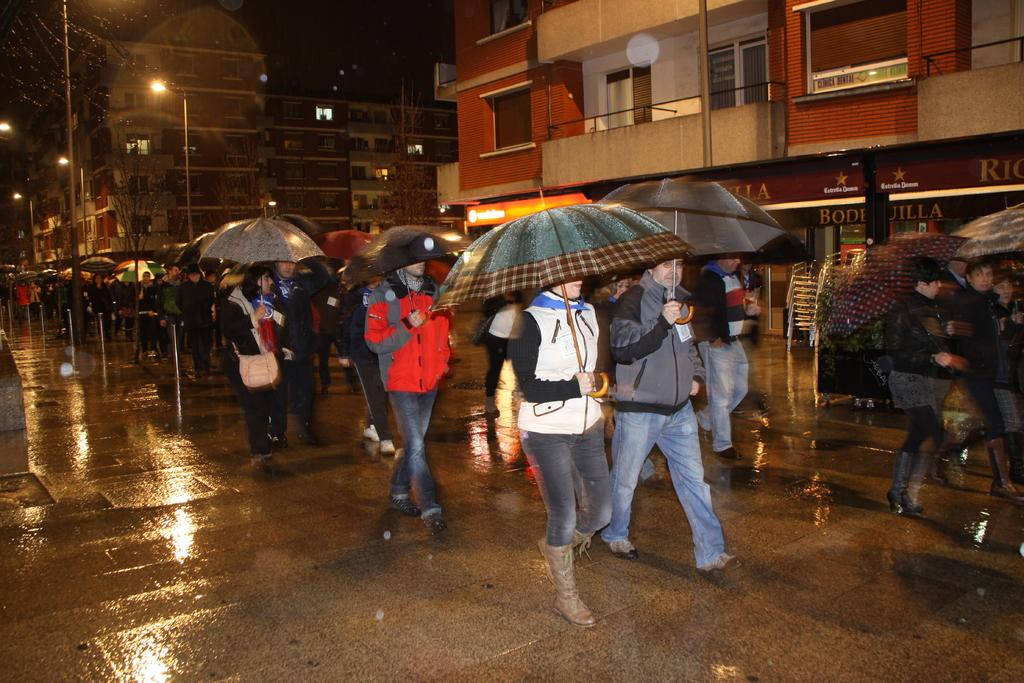How many people are in the image? There is a group of people in the image. What are the people in the image doing? The people are walking on the road. What might the people be holding to protect themselves from the weather? Some people are holding umbrellas. What can be seen in the background of the image? There are poles, lights, buildings, and trees in the background of the image. What type of crib is visible in the image? There is no crib present in the image. Can you tell me which actor is walking in the front of the group? The image does not identify any actors, as it is a candid scene of people walking on the road. 